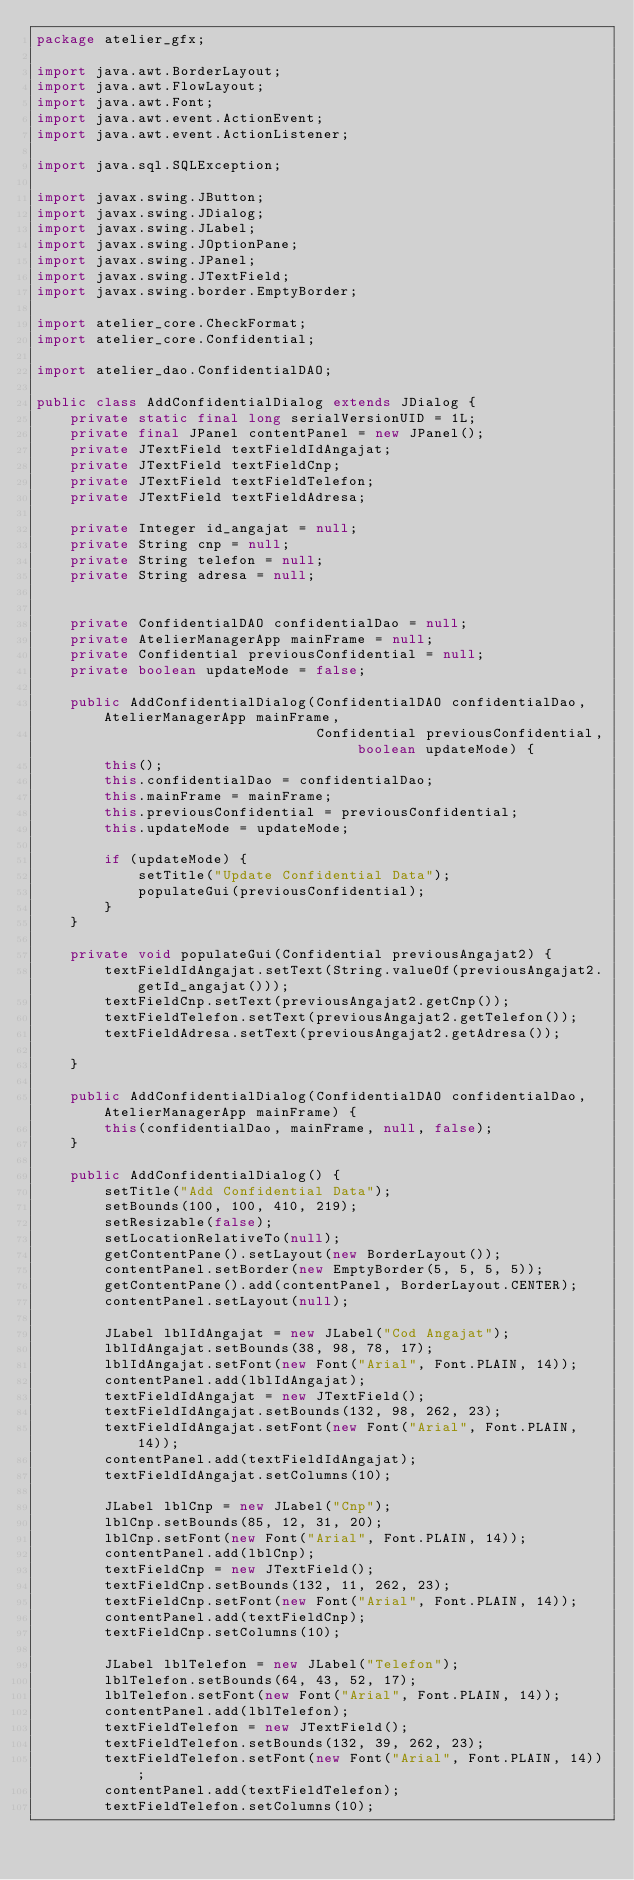<code> <loc_0><loc_0><loc_500><loc_500><_Java_>package atelier_gfx;

import java.awt.BorderLayout;
import java.awt.FlowLayout;
import java.awt.Font;
import java.awt.event.ActionEvent;
import java.awt.event.ActionListener;

import java.sql.SQLException;

import javax.swing.JButton;
import javax.swing.JDialog;
import javax.swing.JLabel;
import javax.swing.JOptionPane;
import javax.swing.JPanel;
import javax.swing.JTextField;
import javax.swing.border.EmptyBorder;

import atelier_core.CheckFormat;
import atelier_core.Confidential;

import atelier_dao.ConfidentialDAO;

public class AddConfidentialDialog extends JDialog {
    private static final long serialVersionUID = 1L;
    private final JPanel contentPanel = new JPanel();
    private JTextField textFieldIdAngajat;
    private JTextField textFieldCnp;
    private JTextField textFieldTelefon;
    private JTextField textFieldAdresa;

    private Integer id_angajat = null;
    private String cnp = null;
    private String telefon = null;
    private String adresa = null;


    private ConfidentialDAO confidentialDao = null;
    private AtelierManagerApp mainFrame = null;
    private Confidential previousConfidential = null;
    private boolean updateMode = false;

    public AddConfidentialDialog(ConfidentialDAO confidentialDao, AtelierManagerApp mainFrame,
                                 Confidential previousConfidential, boolean updateMode) {
        this();
        this.confidentialDao = confidentialDao;
        this.mainFrame = mainFrame;
        this.previousConfidential = previousConfidential;
        this.updateMode = updateMode;

        if (updateMode) {
            setTitle("Update Confidential Data");
            populateGui(previousConfidential);
        }
    }

    private void populateGui(Confidential previousAngajat2) {
        textFieldIdAngajat.setText(String.valueOf(previousAngajat2.getId_angajat()));
        textFieldCnp.setText(previousAngajat2.getCnp());
        textFieldTelefon.setText(previousAngajat2.getTelefon());
        textFieldAdresa.setText(previousAngajat2.getAdresa());

    }

    public AddConfidentialDialog(ConfidentialDAO confidentialDao, AtelierManagerApp mainFrame) {
        this(confidentialDao, mainFrame, null, false);
    }

    public AddConfidentialDialog() {
        setTitle("Add Confidential Data");
        setBounds(100, 100, 410, 219);
        setResizable(false);
        setLocationRelativeTo(null);
        getContentPane().setLayout(new BorderLayout());
        contentPanel.setBorder(new EmptyBorder(5, 5, 5, 5));
        getContentPane().add(contentPanel, BorderLayout.CENTER);
        contentPanel.setLayout(null);

        JLabel lblIdAngajat = new JLabel("Cod Angajat");
        lblIdAngajat.setBounds(38, 98, 78, 17);
        lblIdAngajat.setFont(new Font("Arial", Font.PLAIN, 14));
        contentPanel.add(lblIdAngajat);
        textFieldIdAngajat = new JTextField();
        textFieldIdAngajat.setBounds(132, 98, 262, 23);
        textFieldIdAngajat.setFont(new Font("Arial", Font.PLAIN, 14));
        contentPanel.add(textFieldIdAngajat);
        textFieldIdAngajat.setColumns(10);

        JLabel lblCnp = new JLabel("Cnp");
        lblCnp.setBounds(85, 12, 31, 20);
        lblCnp.setFont(new Font("Arial", Font.PLAIN, 14));
        contentPanel.add(lblCnp);
        textFieldCnp = new JTextField();
        textFieldCnp.setBounds(132, 11, 262, 23);
        textFieldCnp.setFont(new Font("Arial", Font.PLAIN, 14));
        contentPanel.add(textFieldCnp);
        textFieldCnp.setColumns(10);

        JLabel lblTelefon = new JLabel("Telefon");
        lblTelefon.setBounds(64, 43, 52, 17);
        lblTelefon.setFont(new Font("Arial", Font.PLAIN, 14));
        contentPanel.add(lblTelefon);
        textFieldTelefon = new JTextField();
        textFieldTelefon.setBounds(132, 39, 262, 23);
        textFieldTelefon.setFont(new Font("Arial", Font.PLAIN, 14));
        contentPanel.add(textFieldTelefon);
        textFieldTelefon.setColumns(10);
</code> 